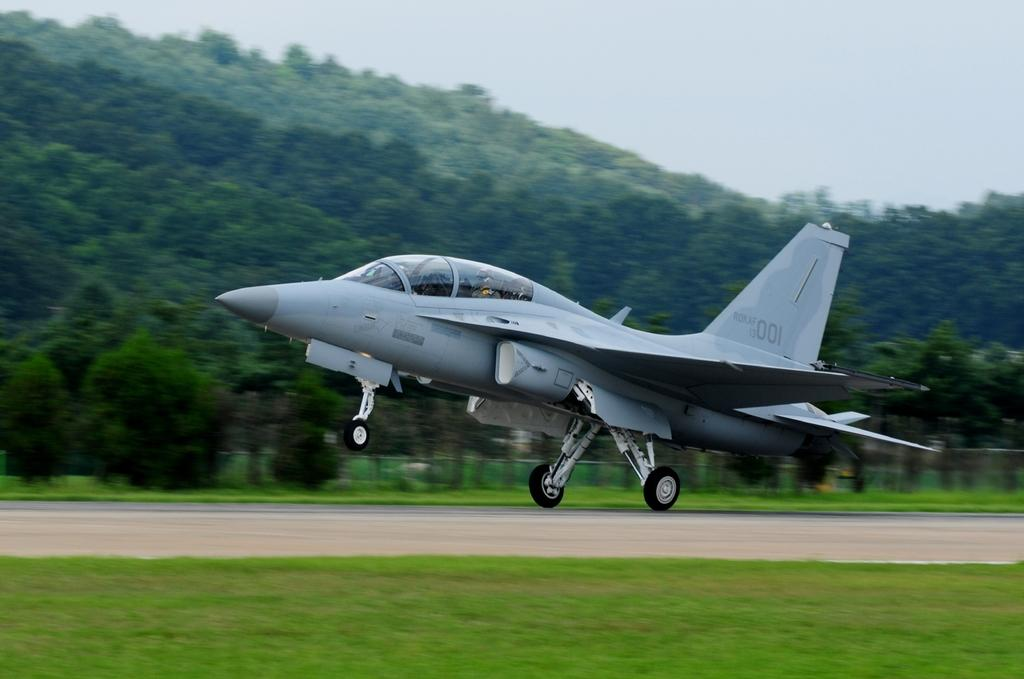<image>
Present a compact description of the photo's key features. A small jet can be seen with the numbers 001 fainly on the tail. 